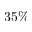<formula> <loc_0><loc_0><loc_500><loc_500>3 5 \%</formula> 